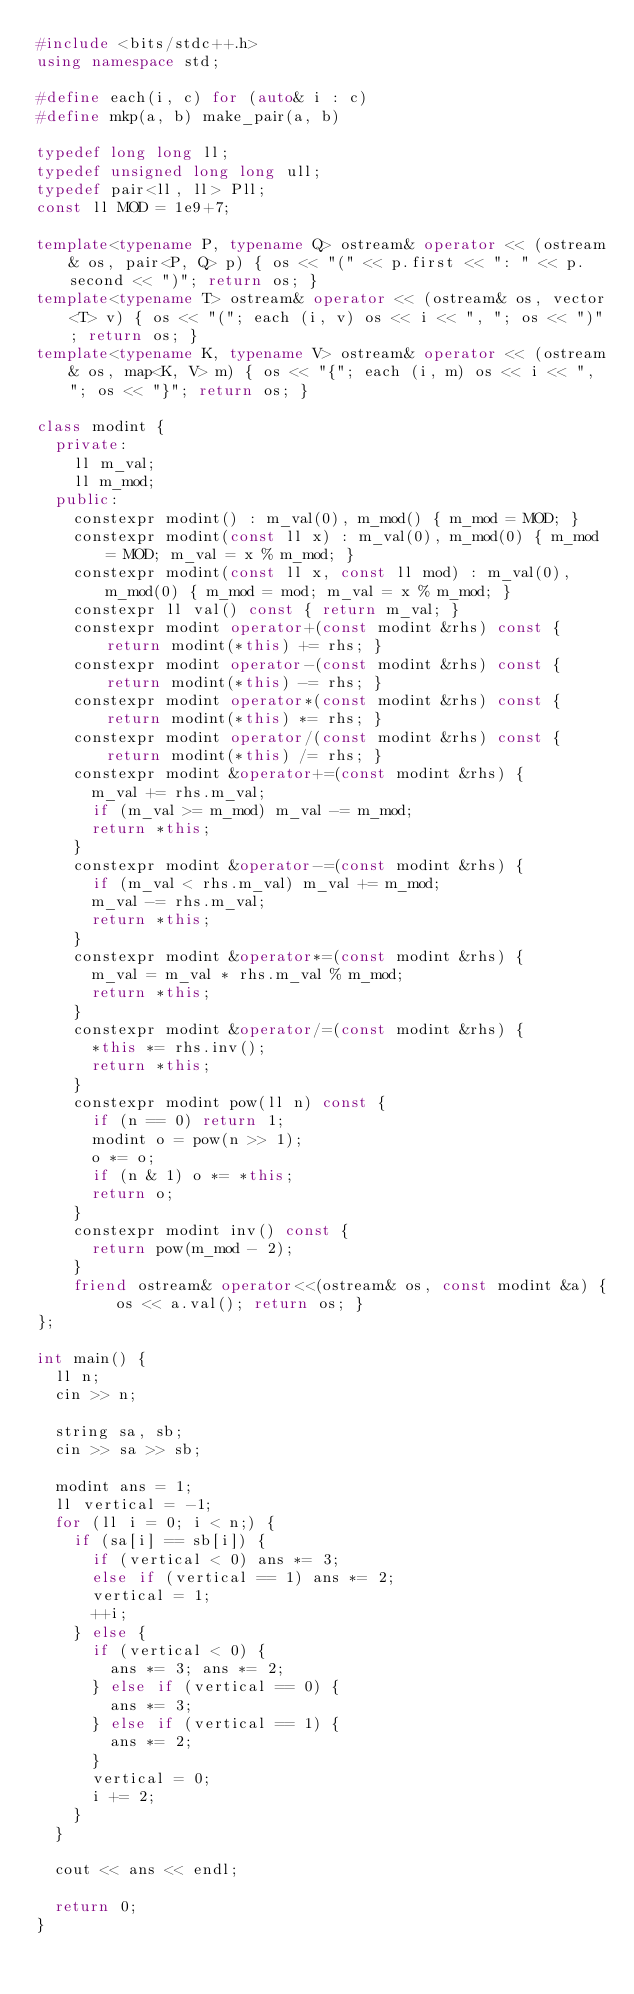<code> <loc_0><loc_0><loc_500><loc_500><_C++_>#include <bits/stdc++.h>
using namespace std;

#define each(i, c) for (auto& i : c)
#define mkp(a, b) make_pair(a, b)

typedef long long ll;
typedef unsigned long long ull;
typedef pair<ll, ll> Pll;
const ll MOD = 1e9+7;

template<typename P, typename Q> ostream& operator << (ostream& os, pair<P, Q> p) { os << "(" << p.first << ": " << p.second << ")"; return os; }
template<typename T> ostream& operator << (ostream& os, vector<T> v) { os << "("; each (i, v) os << i << ", "; os << ")"; return os; }
template<typename K, typename V> ostream& operator << (ostream& os, map<K, V> m) { os << "{"; each (i, m) os << i << ", "; os << "}"; return os; }

class modint {
  private:
    ll m_val;
    ll m_mod;
  public:
    constexpr modint() : m_val(0), m_mod() { m_mod = MOD; }
    constexpr modint(const ll x) : m_val(0), m_mod(0) { m_mod = MOD; m_val = x % m_mod; }
    constexpr modint(const ll x, const ll mod) : m_val(0), m_mod(0) { m_mod = mod; m_val = x % m_mod; }
    constexpr ll val() const { return m_val; }
    constexpr modint operator+(const modint &rhs) const { return modint(*this) += rhs; }
    constexpr modint operator-(const modint &rhs) const { return modint(*this) -= rhs; }
    constexpr modint operator*(const modint &rhs) const { return modint(*this) *= rhs; }
    constexpr modint operator/(const modint &rhs) const { return modint(*this) /= rhs; }
    constexpr modint &operator+=(const modint &rhs) {
      m_val += rhs.m_val;
      if (m_val >= m_mod) m_val -= m_mod;
      return *this;
    }
    constexpr modint &operator-=(const modint &rhs) {
      if (m_val < rhs.m_val) m_val += m_mod;
      m_val -= rhs.m_val;
      return *this;
    }
    constexpr modint &operator*=(const modint &rhs) {
      m_val = m_val * rhs.m_val % m_mod;
      return *this;
    }
    constexpr modint &operator/=(const modint &rhs) {
      *this *= rhs.inv();
      return *this;
    }
    constexpr modint pow(ll n) const {
      if (n == 0) return 1;
      modint o = pow(n >> 1);
      o *= o;
      if (n & 1) o *= *this;
      return o;
    }
    constexpr modint inv() const {
      return pow(m_mod - 2);
    }
    friend ostream& operator<<(ostream& os, const modint &a) { os << a.val(); return os; }
};

int main() {
  ll n;
  cin >> n;

  string sa, sb;
  cin >> sa >> sb;

  modint ans = 1;
  ll vertical = -1;
  for (ll i = 0; i < n;) {
    if (sa[i] == sb[i]) {
      if (vertical < 0) ans *= 3;
      else if (vertical == 1) ans *= 2;
      vertical = 1;
      ++i;
    } else {
      if (vertical < 0) {
        ans *= 3; ans *= 2;
      } else if (vertical == 0) {
        ans *= 3;
      } else if (vertical == 1) {
        ans *= 2;
      }
      vertical = 0;
      i += 2;
    }
  }

  cout << ans << endl;

  return 0;
}
</code> 